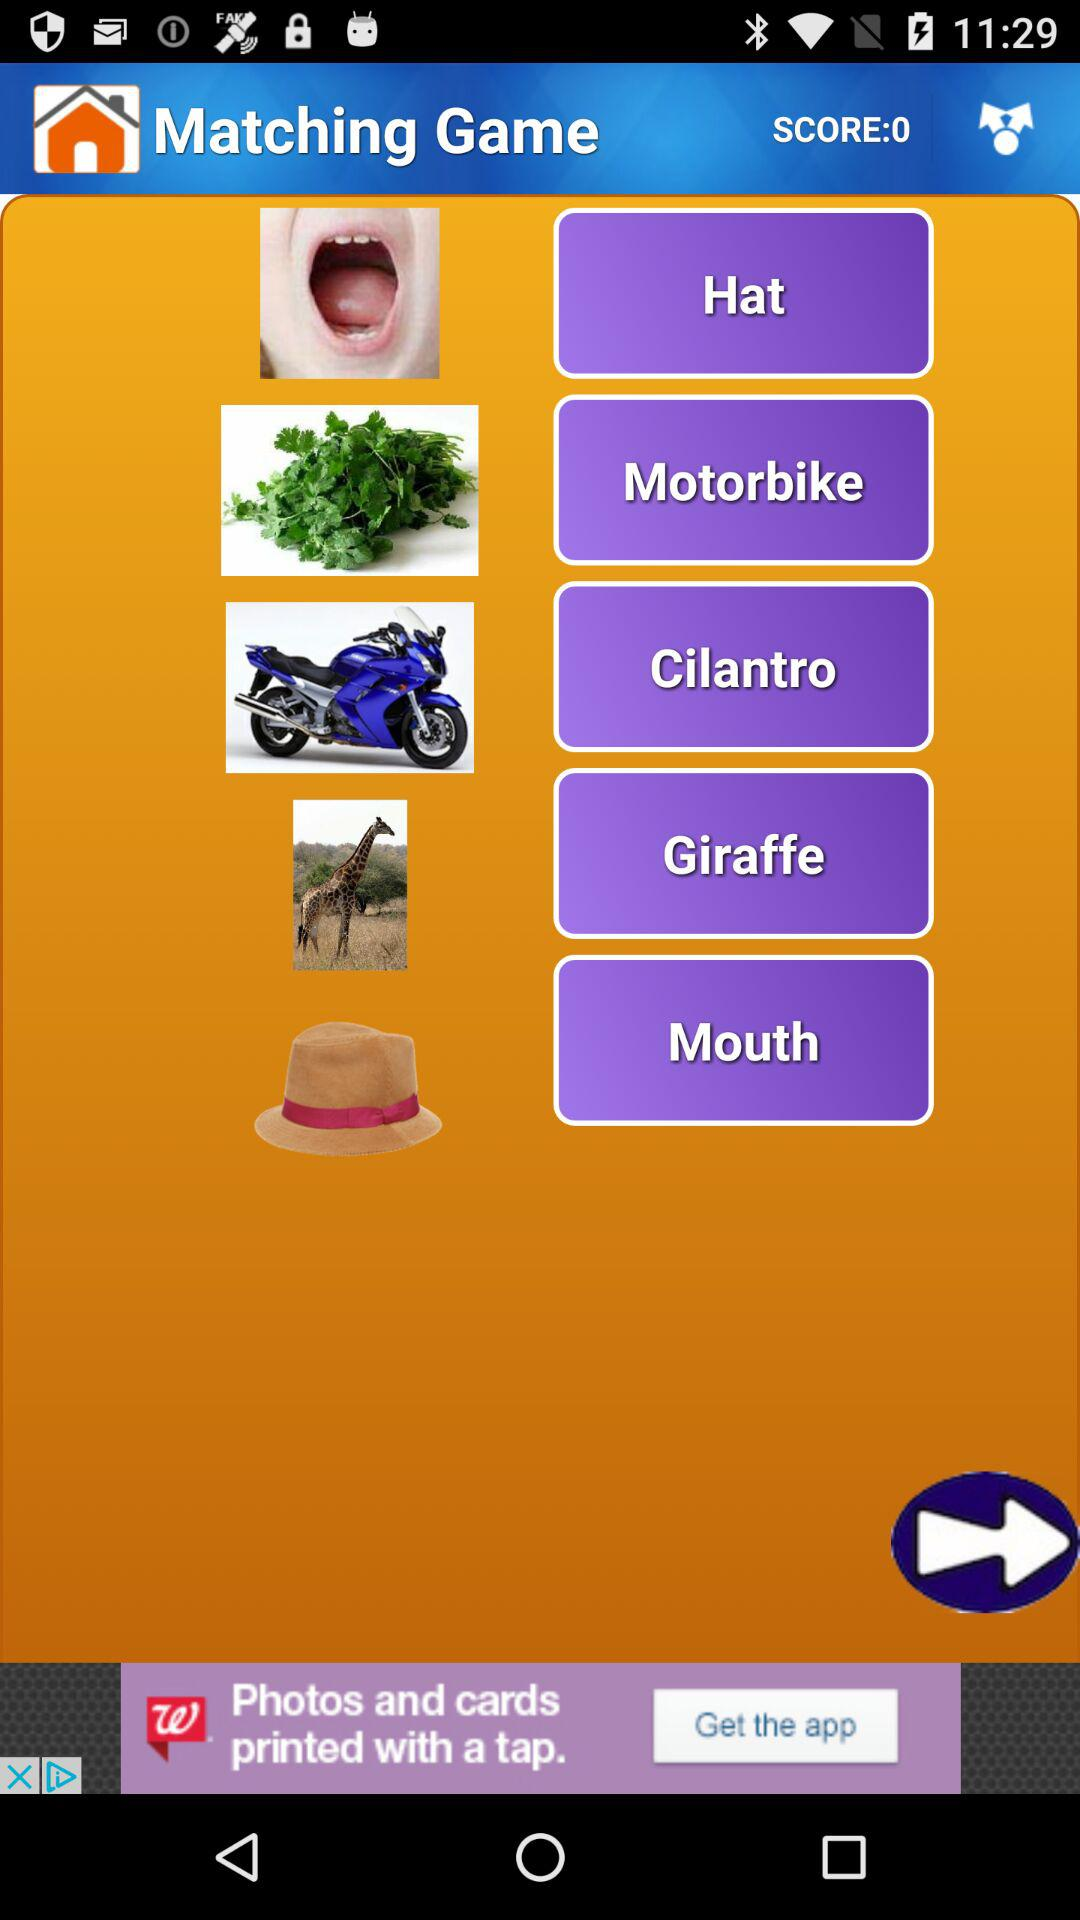What is the score of matching game? The score of the matching game is 0. 